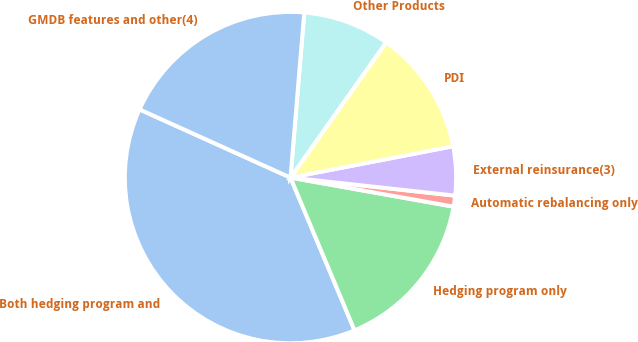<chart> <loc_0><loc_0><loc_500><loc_500><pie_chart><fcel>Both hedging program and<fcel>Hedging program only<fcel>Automatic rebalancing only<fcel>External reinsurance(3)<fcel>PDI<fcel>Other Products<fcel>GMDB features and other(4)<nl><fcel>38.07%<fcel>15.87%<fcel>1.07%<fcel>4.77%<fcel>12.17%<fcel>8.47%<fcel>19.57%<nl></chart> 